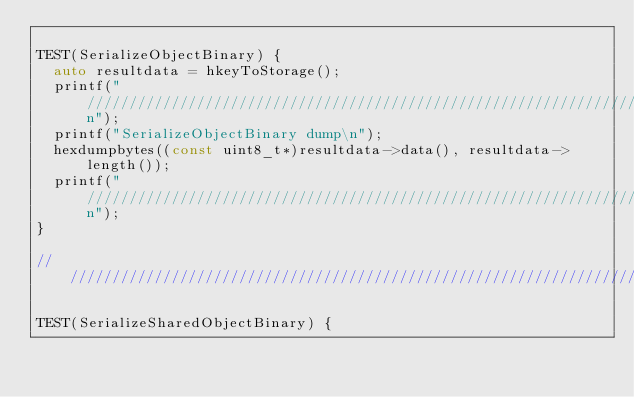Convert code to text. <code><loc_0><loc_0><loc_500><loc_500><_C++_>
TEST(SerializeObjectBinary) {
  auto resultdata = hkeyToStorage();
  printf("////////////////////////////////////////////////////////////////////////\n");
  printf("SerializeObjectBinary dump\n");
  hexdumpbytes((const uint8_t*)resultdata->data(), resultdata->length());
  printf("////////////////////////////////////////////////////////////////////////\n");
}

///////////////////////////////////////////////////////////////////////////////

TEST(SerializeSharedObjectBinary) {</code> 